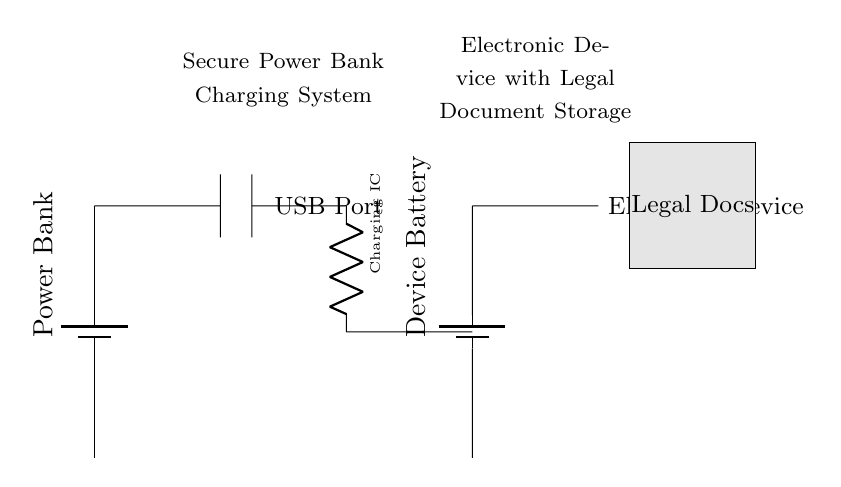What component is responsible for charging the device? The charging integrated circuit is responsible for managing the charging process to the electronic device. It connects the power bank to the device battery for efficient charging.
Answer: Charging IC What type of connection is used between the USB port and the charging IC? The connection between the USB port and the charging IC is a short connection, which signifies direct electrical connectivity without any active components in between.
Answer: Short What is represented by the gray rectangle in the circuit? The gray rectangle symbolizes the storage area where legal documents are kept within the electronic device, indicating the functionality of the device in terms of data storage.
Answer: Legal Docs What is the function of the power bank in this circuit? The power bank serves as the energy source, providing the necessary voltage and current to charge the electronic device's battery. It acts as a reserve power solution.
Answer: Energy source How many main components are involved in the charging process illustrated? There are four main components involved in this charging process: the power bank, USB port, charging IC, and the electronic device with its battery. Each plays a crucial role in the circuit's operation.
Answer: Four What type of device is being charged according to the circuit diagram? The circuit diagram indicates that an electronic device, specifically designed for storing legal documents, is being charged by the power bank.
Answer: Electronic Device 